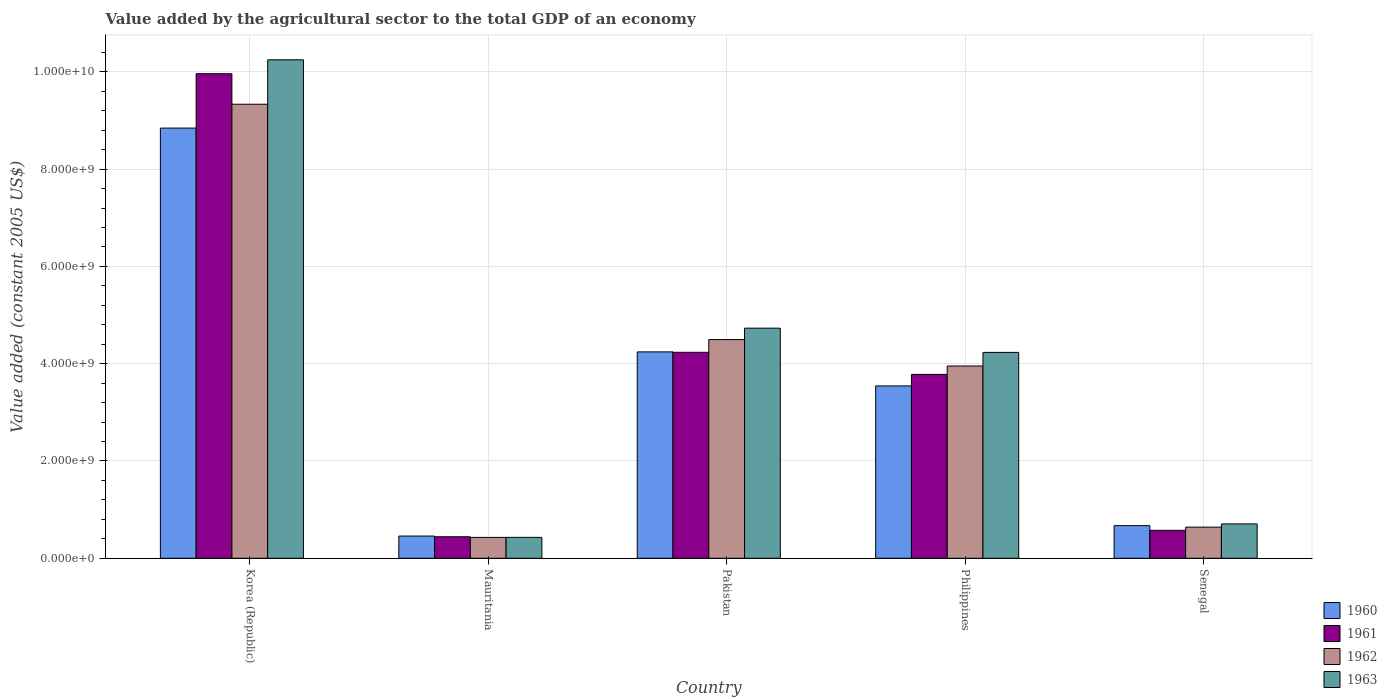How many groups of bars are there?
Provide a short and direct response. 5. Are the number of bars per tick equal to the number of legend labels?
Give a very brief answer. Yes. Are the number of bars on each tick of the X-axis equal?
Make the answer very short. Yes. What is the label of the 2nd group of bars from the left?
Make the answer very short. Mauritania. In how many cases, is the number of bars for a given country not equal to the number of legend labels?
Your answer should be compact. 0. What is the value added by the agricultural sector in 1962 in Philippines?
Provide a succinct answer. 3.95e+09. Across all countries, what is the maximum value added by the agricultural sector in 1963?
Your answer should be very brief. 1.02e+1. Across all countries, what is the minimum value added by the agricultural sector in 1962?
Offer a very short reply. 4.29e+08. In which country was the value added by the agricultural sector in 1960 minimum?
Make the answer very short. Mauritania. What is the total value added by the agricultural sector in 1960 in the graph?
Your answer should be very brief. 1.78e+1. What is the difference between the value added by the agricultural sector in 1962 in Mauritania and that in Senegal?
Provide a short and direct response. -2.11e+08. What is the difference between the value added by the agricultural sector in 1960 in Mauritania and the value added by the agricultural sector in 1961 in Pakistan?
Make the answer very short. -3.78e+09. What is the average value added by the agricultural sector in 1960 per country?
Your response must be concise. 3.55e+09. What is the difference between the value added by the agricultural sector of/in 1962 and value added by the agricultural sector of/in 1963 in Mauritania?
Provide a succinct answer. -7.06e+05. In how many countries, is the value added by the agricultural sector in 1963 greater than 800000000 US$?
Keep it short and to the point. 3. What is the ratio of the value added by the agricultural sector in 1962 in Korea (Republic) to that in Pakistan?
Your answer should be very brief. 2.08. What is the difference between the highest and the second highest value added by the agricultural sector in 1963?
Your answer should be very brief. 5.52e+09. What is the difference between the highest and the lowest value added by the agricultural sector in 1960?
Your answer should be compact. 8.39e+09. Is the sum of the value added by the agricultural sector in 1963 in Pakistan and Senegal greater than the maximum value added by the agricultural sector in 1960 across all countries?
Make the answer very short. No. Is it the case that in every country, the sum of the value added by the agricultural sector in 1961 and value added by the agricultural sector in 1963 is greater than the value added by the agricultural sector in 1960?
Your answer should be compact. Yes. How many bars are there?
Your response must be concise. 20. Are all the bars in the graph horizontal?
Your answer should be very brief. No. What is the difference between two consecutive major ticks on the Y-axis?
Make the answer very short. 2.00e+09. Are the values on the major ticks of Y-axis written in scientific E-notation?
Make the answer very short. Yes. How many legend labels are there?
Ensure brevity in your answer.  4. What is the title of the graph?
Your response must be concise. Value added by the agricultural sector to the total GDP of an economy. Does "1963" appear as one of the legend labels in the graph?
Make the answer very short. Yes. What is the label or title of the Y-axis?
Make the answer very short. Value added (constant 2005 US$). What is the Value added (constant 2005 US$) in 1960 in Korea (Republic)?
Make the answer very short. 8.84e+09. What is the Value added (constant 2005 US$) of 1961 in Korea (Republic)?
Offer a terse response. 9.96e+09. What is the Value added (constant 2005 US$) of 1962 in Korea (Republic)?
Your answer should be compact. 9.33e+09. What is the Value added (constant 2005 US$) in 1963 in Korea (Republic)?
Provide a short and direct response. 1.02e+1. What is the Value added (constant 2005 US$) in 1960 in Mauritania?
Ensure brevity in your answer.  4.57e+08. What is the Value added (constant 2005 US$) of 1961 in Mauritania?
Offer a very short reply. 4.42e+08. What is the Value added (constant 2005 US$) of 1962 in Mauritania?
Make the answer very short. 4.29e+08. What is the Value added (constant 2005 US$) of 1963 in Mauritania?
Provide a short and direct response. 4.30e+08. What is the Value added (constant 2005 US$) of 1960 in Pakistan?
Provide a short and direct response. 4.24e+09. What is the Value added (constant 2005 US$) of 1961 in Pakistan?
Give a very brief answer. 4.23e+09. What is the Value added (constant 2005 US$) in 1962 in Pakistan?
Provide a succinct answer. 4.50e+09. What is the Value added (constant 2005 US$) in 1963 in Pakistan?
Offer a terse response. 4.73e+09. What is the Value added (constant 2005 US$) of 1960 in Philippines?
Offer a very short reply. 3.54e+09. What is the Value added (constant 2005 US$) in 1961 in Philippines?
Keep it short and to the point. 3.78e+09. What is the Value added (constant 2005 US$) in 1962 in Philippines?
Offer a terse response. 3.95e+09. What is the Value added (constant 2005 US$) in 1963 in Philippines?
Keep it short and to the point. 4.23e+09. What is the Value added (constant 2005 US$) in 1960 in Senegal?
Give a very brief answer. 6.70e+08. What is the Value added (constant 2005 US$) in 1961 in Senegal?
Provide a succinct answer. 5.74e+08. What is the Value added (constant 2005 US$) of 1962 in Senegal?
Your response must be concise. 6.40e+08. What is the Value added (constant 2005 US$) in 1963 in Senegal?
Your answer should be compact. 7.06e+08. Across all countries, what is the maximum Value added (constant 2005 US$) of 1960?
Your response must be concise. 8.84e+09. Across all countries, what is the maximum Value added (constant 2005 US$) in 1961?
Ensure brevity in your answer.  9.96e+09. Across all countries, what is the maximum Value added (constant 2005 US$) in 1962?
Provide a succinct answer. 9.33e+09. Across all countries, what is the maximum Value added (constant 2005 US$) of 1963?
Give a very brief answer. 1.02e+1. Across all countries, what is the minimum Value added (constant 2005 US$) in 1960?
Offer a very short reply. 4.57e+08. Across all countries, what is the minimum Value added (constant 2005 US$) of 1961?
Provide a succinct answer. 4.42e+08. Across all countries, what is the minimum Value added (constant 2005 US$) of 1962?
Provide a succinct answer. 4.29e+08. Across all countries, what is the minimum Value added (constant 2005 US$) of 1963?
Ensure brevity in your answer.  4.30e+08. What is the total Value added (constant 2005 US$) of 1960 in the graph?
Keep it short and to the point. 1.78e+1. What is the total Value added (constant 2005 US$) of 1961 in the graph?
Offer a very short reply. 1.90e+1. What is the total Value added (constant 2005 US$) in 1962 in the graph?
Make the answer very short. 1.89e+1. What is the total Value added (constant 2005 US$) of 1963 in the graph?
Provide a short and direct response. 2.03e+1. What is the difference between the Value added (constant 2005 US$) in 1960 in Korea (Republic) and that in Mauritania?
Offer a terse response. 8.39e+09. What is the difference between the Value added (constant 2005 US$) in 1961 in Korea (Republic) and that in Mauritania?
Provide a short and direct response. 9.52e+09. What is the difference between the Value added (constant 2005 US$) of 1962 in Korea (Republic) and that in Mauritania?
Your answer should be very brief. 8.91e+09. What is the difference between the Value added (constant 2005 US$) in 1963 in Korea (Republic) and that in Mauritania?
Provide a succinct answer. 9.82e+09. What is the difference between the Value added (constant 2005 US$) in 1960 in Korea (Republic) and that in Pakistan?
Provide a short and direct response. 4.60e+09. What is the difference between the Value added (constant 2005 US$) in 1961 in Korea (Republic) and that in Pakistan?
Your answer should be very brief. 5.73e+09. What is the difference between the Value added (constant 2005 US$) in 1962 in Korea (Republic) and that in Pakistan?
Offer a very short reply. 4.84e+09. What is the difference between the Value added (constant 2005 US$) in 1963 in Korea (Republic) and that in Pakistan?
Provide a succinct answer. 5.52e+09. What is the difference between the Value added (constant 2005 US$) in 1960 in Korea (Republic) and that in Philippines?
Your answer should be compact. 5.30e+09. What is the difference between the Value added (constant 2005 US$) in 1961 in Korea (Republic) and that in Philippines?
Give a very brief answer. 6.18e+09. What is the difference between the Value added (constant 2005 US$) in 1962 in Korea (Republic) and that in Philippines?
Make the answer very short. 5.38e+09. What is the difference between the Value added (constant 2005 US$) in 1963 in Korea (Republic) and that in Philippines?
Make the answer very short. 6.02e+09. What is the difference between the Value added (constant 2005 US$) of 1960 in Korea (Republic) and that in Senegal?
Make the answer very short. 8.17e+09. What is the difference between the Value added (constant 2005 US$) in 1961 in Korea (Republic) and that in Senegal?
Offer a very short reply. 9.39e+09. What is the difference between the Value added (constant 2005 US$) of 1962 in Korea (Republic) and that in Senegal?
Provide a succinct answer. 8.69e+09. What is the difference between the Value added (constant 2005 US$) in 1963 in Korea (Republic) and that in Senegal?
Keep it short and to the point. 9.54e+09. What is the difference between the Value added (constant 2005 US$) in 1960 in Mauritania and that in Pakistan?
Your answer should be very brief. -3.79e+09. What is the difference between the Value added (constant 2005 US$) of 1961 in Mauritania and that in Pakistan?
Your answer should be compact. -3.79e+09. What is the difference between the Value added (constant 2005 US$) in 1962 in Mauritania and that in Pakistan?
Keep it short and to the point. -4.07e+09. What is the difference between the Value added (constant 2005 US$) of 1963 in Mauritania and that in Pakistan?
Make the answer very short. -4.30e+09. What is the difference between the Value added (constant 2005 US$) of 1960 in Mauritania and that in Philippines?
Your answer should be compact. -3.09e+09. What is the difference between the Value added (constant 2005 US$) in 1961 in Mauritania and that in Philippines?
Give a very brief answer. -3.34e+09. What is the difference between the Value added (constant 2005 US$) of 1962 in Mauritania and that in Philippines?
Offer a terse response. -3.52e+09. What is the difference between the Value added (constant 2005 US$) of 1963 in Mauritania and that in Philippines?
Ensure brevity in your answer.  -3.80e+09. What is the difference between the Value added (constant 2005 US$) in 1960 in Mauritania and that in Senegal?
Make the answer very short. -2.14e+08. What is the difference between the Value added (constant 2005 US$) of 1961 in Mauritania and that in Senegal?
Give a very brief answer. -1.32e+08. What is the difference between the Value added (constant 2005 US$) in 1962 in Mauritania and that in Senegal?
Ensure brevity in your answer.  -2.11e+08. What is the difference between the Value added (constant 2005 US$) in 1963 in Mauritania and that in Senegal?
Your answer should be compact. -2.77e+08. What is the difference between the Value added (constant 2005 US$) of 1960 in Pakistan and that in Philippines?
Make the answer very short. 7.00e+08. What is the difference between the Value added (constant 2005 US$) in 1961 in Pakistan and that in Philippines?
Offer a very short reply. 4.54e+08. What is the difference between the Value added (constant 2005 US$) in 1962 in Pakistan and that in Philippines?
Offer a very short reply. 5.44e+08. What is the difference between the Value added (constant 2005 US$) of 1963 in Pakistan and that in Philippines?
Keep it short and to the point. 4.98e+08. What is the difference between the Value added (constant 2005 US$) of 1960 in Pakistan and that in Senegal?
Offer a terse response. 3.57e+09. What is the difference between the Value added (constant 2005 US$) of 1961 in Pakistan and that in Senegal?
Give a very brief answer. 3.66e+09. What is the difference between the Value added (constant 2005 US$) of 1962 in Pakistan and that in Senegal?
Make the answer very short. 3.86e+09. What is the difference between the Value added (constant 2005 US$) in 1963 in Pakistan and that in Senegal?
Ensure brevity in your answer.  4.02e+09. What is the difference between the Value added (constant 2005 US$) in 1960 in Philippines and that in Senegal?
Provide a succinct answer. 2.87e+09. What is the difference between the Value added (constant 2005 US$) of 1961 in Philippines and that in Senegal?
Your answer should be very brief. 3.21e+09. What is the difference between the Value added (constant 2005 US$) of 1962 in Philippines and that in Senegal?
Offer a terse response. 3.31e+09. What is the difference between the Value added (constant 2005 US$) of 1963 in Philippines and that in Senegal?
Ensure brevity in your answer.  3.53e+09. What is the difference between the Value added (constant 2005 US$) in 1960 in Korea (Republic) and the Value added (constant 2005 US$) in 1961 in Mauritania?
Keep it short and to the point. 8.40e+09. What is the difference between the Value added (constant 2005 US$) in 1960 in Korea (Republic) and the Value added (constant 2005 US$) in 1962 in Mauritania?
Ensure brevity in your answer.  8.41e+09. What is the difference between the Value added (constant 2005 US$) of 1960 in Korea (Republic) and the Value added (constant 2005 US$) of 1963 in Mauritania?
Ensure brevity in your answer.  8.41e+09. What is the difference between the Value added (constant 2005 US$) of 1961 in Korea (Republic) and the Value added (constant 2005 US$) of 1962 in Mauritania?
Offer a very short reply. 9.53e+09. What is the difference between the Value added (constant 2005 US$) in 1961 in Korea (Republic) and the Value added (constant 2005 US$) in 1963 in Mauritania?
Provide a short and direct response. 9.53e+09. What is the difference between the Value added (constant 2005 US$) of 1962 in Korea (Republic) and the Value added (constant 2005 US$) of 1963 in Mauritania?
Your response must be concise. 8.90e+09. What is the difference between the Value added (constant 2005 US$) in 1960 in Korea (Republic) and the Value added (constant 2005 US$) in 1961 in Pakistan?
Make the answer very short. 4.61e+09. What is the difference between the Value added (constant 2005 US$) in 1960 in Korea (Republic) and the Value added (constant 2005 US$) in 1962 in Pakistan?
Your answer should be very brief. 4.35e+09. What is the difference between the Value added (constant 2005 US$) of 1960 in Korea (Republic) and the Value added (constant 2005 US$) of 1963 in Pakistan?
Offer a terse response. 4.11e+09. What is the difference between the Value added (constant 2005 US$) in 1961 in Korea (Republic) and the Value added (constant 2005 US$) in 1962 in Pakistan?
Provide a succinct answer. 5.46e+09. What is the difference between the Value added (constant 2005 US$) of 1961 in Korea (Republic) and the Value added (constant 2005 US$) of 1963 in Pakistan?
Your answer should be compact. 5.23e+09. What is the difference between the Value added (constant 2005 US$) in 1962 in Korea (Republic) and the Value added (constant 2005 US$) in 1963 in Pakistan?
Your answer should be compact. 4.60e+09. What is the difference between the Value added (constant 2005 US$) in 1960 in Korea (Republic) and the Value added (constant 2005 US$) in 1961 in Philippines?
Provide a succinct answer. 5.06e+09. What is the difference between the Value added (constant 2005 US$) in 1960 in Korea (Republic) and the Value added (constant 2005 US$) in 1962 in Philippines?
Keep it short and to the point. 4.89e+09. What is the difference between the Value added (constant 2005 US$) of 1960 in Korea (Republic) and the Value added (constant 2005 US$) of 1963 in Philippines?
Keep it short and to the point. 4.61e+09. What is the difference between the Value added (constant 2005 US$) in 1961 in Korea (Republic) and the Value added (constant 2005 US$) in 1962 in Philippines?
Provide a short and direct response. 6.01e+09. What is the difference between the Value added (constant 2005 US$) in 1961 in Korea (Republic) and the Value added (constant 2005 US$) in 1963 in Philippines?
Offer a very short reply. 5.73e+09. What is the difference between the Value added (constant 2005 US$) of 1962 in Korea (Republic) and the Value added (constant 2005 US$) of 1963 in Philippines?
Provide a short and direct response. 5.10e+09. What is the difference between the Value added (constant 2005 US$) in 1960 in Korea (Republic) and the Value added (constant 2005 US$) in 1961 in Senegal?
Your answer should be very brief. 8.27e+09. What is the difference between the Value added (constant 2005 US$) in 1960 in Korea (Republic) and the Value added (constant 2005 US$) in 1962 in Senegal?
Provide a succinct answer. 8.20e+09. What is the difference between the Value added (constant 2005 US$) of 1960 in Korea (Republic) and the Value added (constant 2005 US$) of 1963 in Senegal?
Your answer should be compact. 8.14e+09. What is the difference between the Value added (constant 2005 US$) of 1961 in Korea (Republic) and the Value added (constant 2005 US$) of 1962 in Senegal?
Keep it short and to the point. 9.32e+09. What is the difference between the Value added (constant 2005 US$) of 1961 in Korea (Republic) and the Value added (constant 2005 US$) of 1963 in Senegal?
Offer a very short reply. 9.25e+09. What is the difference between the Value added (constant 2005 US$) of 1962 in Korea (Republic) and the Value added (constant 2005 US$) of 1963 in Senegal?
Offer a very short reply. 8.63e+09. What is the difference between the Value added (constant 2005 US$) of 1960 in Mauritania and the Value added (constant 2005 US$) of 1961 in Pakistan?
Your response must be concise. -3.78e+09. What is the difference between the Value added (constant 2005 US$) in 1960 in Mauritania and the Value added (constant 2005 US$) in 1962 in Pakistan?
Ensure brevity in your answer.  -4.04e+09. What is the difference between the Value added (constant 2005 US$) in 1960 in Mauritania and the Value added (constant 2005 US$) in 1963 in Pakistan?
Provide a short and direct response. -4.27e+09. What is the difference between the Value added (constant 2005 US$) in 1961 in Mauritania and the Value added (constant 2005 US$) in 1962 in Pakistan?
Provide a succinct answer. -4.05e+09. What is the difference between the Value added (constant 2005 US$) in 1961 in Mauritania and the Value added (constant 2005 US$) in 1963 in Pakistan?
Ensure brevity in your answer.  -4.29e+09. What is the difference between the Value added (constant 2005 US$) of 1962 in Mauritania and the Value added (constant 2005 US$) of 1963 in Pakistan?
Your response must be concise. -4.30e+09. What is the difference between the Value added (constant 2005 US$) in 1960 in Mauritania and the Value added (constant 2005 US$) in 1961 in Philippines?
Offer a terse response. -3.32e+09. What is the difference between the Value added (constant 2005 US$) in 1960 in Mauritania and the Value added (constant 2005 US$) in 1962 in Philippines?
Your answer should be compact. -3.50e+09. What is the difference between the Value added (constant 2005 US$) in 1960 in Mauritania and the Value added (constant 2005 US$) in 1963 in Philippines?
Your answer should be compact. -3.78e+09. What is the difference between the Value added (constant 2005 US$) of 1961 in Mauritania and the Value added (constant 2005 US$) of 1962 in Philippines?
Keep it short and to the point. -3.51e+09. What is the difference between the Value added (constant 2005 US$) in 1961 in Mauritania and the Value added (constant 2005 US$) in 1963 in Philippines?
Provide a succinct answer. -3.79e+09. What is the difference between the Value added (constant 2005 US$) of 1962 in Mauritania and the Value added (constant 2005 US$) of 1963 in Philippines?
Provide a short and direct response. -3.80e+09. What is the difference between the Value added (constant 2005 US$) in 1960 in Mauritania and the Value added (constant 2005 US$) in 1961 in Senegal?
Your response must be concise. -1.18e+08. What is the difference between the Value added (constant 2005 US$) in 1960 in Mauritania and the Value added (constant 2005 US$) in 1962 in Senegal?
Make the answer very short. -1.83e+08. What is the difference between the Value added (constant 2005 US$) in 1960 in Mauritania and the Value added (constant 2005 US$) in 1963 in Senegal?
Your response must be concise. -2.50e+08. What is the difference between the Value added (constant 2005 US$) of 1961 in Mauritania and the Value added (constant 2005 US$) of 1962 in Senegal?
Your response must be concise. -1.97e+08. What is the difference between the Value added (constant 2005 US$) in 1961 in Mauritania and the Value added (constant 2005 US$) in 1963 in Senegal?
Give a very brief answer. -2.64e+08. What is the difference between the Value added (constant 2005 US$) in 1962 in Mauritania and the Value added (constant 2005 US$) in 1963 in Senegal?
Offer a very short reply. -2.77e+08. What is the difference between the Value added (constant 2005 US$) in 1960 in Pakistan and the Value added (constant 2005 US$) in 1961 in Philippines?
Make the answer very short. 4.62e+08. What is the difference between the Value added (constant 2005 US$) in 1960 in Pakistan and the Value added (constant 2005 US$) in 1962 in Philippines?
Offer a terse response. 2.90e+08. What is the difference between the Value added (constant 2005 US$) in 1960 in Pakistan and the Value added (constant 2005 US$) in 1963 in Philippines?
Give a very brief answer. 1.07e+07. What is the difference between the Value added (constant 2005 US$) in 1961 in Pakistan and the Value added (constant 2005 US$) in 1962 in Philippines?
Make the answer very short. 2.82e+08. What is the difference between the Value added (constant 2005 US$) in 1961 in Pakistan and the Value added (constant 2005 US$) in 1963 in Philippines?
Your response must be concise. 2.10e+06. What is the difference between the Value added (constant 2005 US$) of 1962 in Pakistan and the Value added (constant 2005 US$) of 1963 in Philippines?
Provide a succinct answer. 2.64e+08. What is the difference between the Value added (constant 2005 US$) of 1960 in Pakistan and the Value added (constant 2005 US$) of 1961 in Senegal?
Provide a short and direct response. 3.67e+09. What is the difference between the Value added (constant 2005 US$) of 1960 in Pakistan and the Value added (constant 2005 US$) of 1962 in Senegal?
Ensure brevity in your answer.  3.60e+09. What is the difference between the Value added (constant 2005 US$) in 1960 in Pakistan and the Value added (constant 2005 US$) in 1963 in Senegal?
Keep it short and to the point. 3.54e+09. What is the difference between the Value added (constant 2005 US$) in 1961 in Pakistan and the Value added (constant 2005 US$) in 1962 in Senegal?
Provide a short and direct response. 3.59e+09. What is the difference between the Value added (constant 2005 US$) in 1961 in Pakistan and the Value added (constant 2005 US$) in 1963 in Senegal?
Make the answer very short. 3.53e+09. What is the difference between the Value added (constant 2005 US$) in 1962 in Pakistan and the Value added (constant 2005 US$) in 1963 in Senegal?
Offer a terse response. 3.79e+09. What is the difference between the Value added (constant 2005 US$) of 1960 in Philippines and the Value added (constant 2005 US$) of 1961 in Senegal?
Make the answer very short. 2.97e+09. What is the difference between the Value added (constant 2005 US$) in 1960 in Philippines and the Value added (constant 2005 US$) in 1962 in Senegal?
Ensure brevity in your answer.  2.90e+09. What is the difference between the Value added (constant 2005 US$) in 1960 in Philippines and the Value added (constant 2005 US$) in 1963 in Senegal?
Make the answer very short. 2.84e+09. What is the difference between the Value added (constant 2005 US$) of 1961 in Philippines and the Value added (constant 2005 US$) of 1962 in Senegal?
Ensure brevity in your answer.  3.14e+09. What is the difference between the Value added (constant 2005 US$) in 1961 in Philippines and the Value added (constant 2005 US$) in 1963 in Senegal?
Provide a succinct answer. 3.07e+09. What is the difference between the Value added (constant 2005 US$) in 1962 in Philippines and the Value added (constant 2005 US$) in 1963 in Senegal?
Provide a succinct answer. 3.25e+09. What is the average Value added (constant 2005 US$) of 1960 per country?
Make the answer very short. 3.55e+09. What is the average Value added (constant 2005 US$) in 1961 per country?
Make the answer very short. 3.80e+09. What is the average Value added (constant 2005 US$) of 1962 per country?
Provide a short and direct response. 3.77e+09. What is the average Value added (constant 2005 US$) of 1963 per country?
Provide a short and direct response. 4.07e+09. What is the difference between the Value added (constant 2005 US$) in 1960 and Value added (constant 2005 US$) in 1961 in Korea (Republic)?
Your response must be concise. -1.12e+09. What is the difference between the Value added (constant 2005 US$) of 1960 and Value added (constant 2005 US$) of 1962 in Korea (Republic)?
Offer a terse response. -4.90e+08. What is the difference between the Value added (constant 2005 US$) in 1960 and Value added (constant 2005 US$) in 1963 in Korea (Republic)?
Give a very brief answer. -1.40e+09. What is the difference between the Value added (constant 2005 US$) of 1961 and Value added (constant 2005 US$) of 1962 in Korea (Republic)?
Give a very brief answer. 6.27e+08. What is the difference between the Value added (constant 2005 US$) of 1961 and Value added (constant 2005 US$) of 1963 in Korea (Republic)?
Provide a short and direct response. -2.87e+08. What is the difference between the Value added (constant 2005 US$) of 1962 and Value added (constant 2005 US$) of 1963 in Korea (Republic)?
Provide a succinct answer. -9.14e+08. What is the difference between the Value added (constant 2005 US$) of 1960 and Value added (constant 2005 US$) of 1961 in Mauritania?
Provide a short and direct response. 1.44e+07. What is the difference between the Value added (constant 2005 US$) of 1960 and Value added (constant 2005 US$) of 1962 in Mauritania?
Provide a short and direct response. 2.75e+07. What is the difference between the Value added (constant 2005 US$) in 1960 and Value added (constant 2005 US$) in 1963 in Mauritania?
Provide a short and direct response. 2.68e+07. What is the difference between the Value added (constant 2005 US$) in 1961 and Value added (constant 2005 US$) in 1962 in Mauritania?
Your answer should be very brief. 1.31e+07. What is the difference between the Value added (constant 2005 US$) of 1961 and Value added (constant 2005 US$) of 1963 in Mauritania?
Your answer should be compact. 1.24e+07. What is the difference between the Value added (constant 2005 US$) in 1962 and Value added (constant 2005 US$) in 1963 in Mauritania?
Your answer should be very brief. -7.06e+05. What is the difference between the Value added (constant 2005 US$) of 1960 and Value added (constant 2005 US$) of 1961 in Pakistan?
Your answer should be very brief. 8.56e+06. What is the difference between the Value added (constant 2005 US$) of 1960 and Value added (constant 2005 US$) of 1962 in Pakistan?
Give a very brief answer. -2.53e+08. What is the difference between the Value added (constant 2005 US$) of 1960 and Value added (constant 2005 US$) of 1963 in Pakistan?
Your answer should be very brief. -4.87e+08. What is the difference between the Value added (constant 2005 US$) of 1961 and Value added (constant 2005 US$) of 1962 in Pakistan?
Make the answer very short. -2.62e+08. What is the difference between the Value added (constant 2005 US$) of 1961 and Value added (constant 2005 US$) of 1963 in Pakistan?
Your answer should be very brief. -4.96e+08. What is the difference between the Value added (constant 2005 US$) of 1962 and Value added (constant 2005 US$) of 1963 in Pakistan?
Give a very brief answer. -2.34e+08. What is the difference between the Value added (constant 2005 US$) in 1960 and Value added (constant 2005 US$) in 1961 in Philippines?
Your answer should be very brief. -2.37e+08. What is the difference between the Value added (constant 2005 US$) in 1960 and Value added (constant 2005 US$) in 1962 in Philippines?
Keep it short and to the point. -4.09e+08. What is the difference between the Value added (constant 2005 US$) in 1960 and Value added (constant 2005 US$) in 1963 in Philippines?
Make the answer very short. -6.89e+08. What is the difference between the Value added (constant 2005 US$) in 1961 and Value added (constant 2005 US$) in 1962 in Philippines?
Your response must be concise. -1.72e+08. What is the difference between the Value added (constant 2005 US$) in 1961 and Value added (constant 2005 US$) in 1963 in Philippines?
Ensure brevity in your answer.  -4.52e+08. What is the difference between the Value added (constant 2005 US$) in 1962 and Value added (constant 2005 US$) in 1963 in Philippines?
Ensure brevity in your answer.  -2.80e+08. What is the difference between the Value added (constant 2005 US$) in 1960 and Value added (constant 2005 US$) in 1961 in Senegal?
Your response must be concise. 9.60e+07. What is the difference between the Value added (constant 2005 US$) of 1960 and Value added (constant 2005 US$) of 1962 in Senegal?
Give a very brief answer. 3.06e+07. What is the difference between the Value added (constant 2005 US$) of 1960 and Value added (constant 2005 US$) of 1963 in Senegal?
Make the answer very short. -3.60e+07. What is the difference between the Value added (constant 2005 US$) in 1961 and Value added (constant 2005 US$) in 1962 in Senegal?
Make the answer very short. -6.53e+07. What is the difference between the Value added (constant 2005 US$) of 1961 and Value added (constant 2005 US$) of 1963 in Senegal?
Your response must be concise. -1.32e+08. What is the difference between the Value added (constant 2005 US$) in 1962 and Value added (constant 2005 US$) in 1963 in Senegal?
Ensure brevity in your answer.  -6.67e+07. What is the ratio of the Value added (constant 2005 US$) in 1960 in Korea (Republic) to that in Mauritania?
Your answer should be very brief. 19.37. What is the ratio of the Value added (constant 2005 US$) of 1961 in Korea (Republic) to that in Mauritania?
Ensure brevity in your answer.  22.52. What is the ratio of the Value added (constant 2005 US$) of 1962 in Korea (Republic) to that in Mauritania?
Offer a terse response. 21.75. What is the ratio of the Value added (constant 2005 US$) in 1963 in Korea (Republic) to that in Mauritania?
Ensure brevity in your answer.  23.84. What is the ratio of the Value added (constant 2005 US$) of 1960 in Korea (Republic) to that in Pakistan?
Provide a short and direct response. 2.08. What is the ratio of the Value added (constant 2005 US$) of 1961 in Korea (Republic) to that in Pakistan?
Offer a very short reply. 2.35. What is the ratio of the Value added (constant 2005 US$) of 1962 in Korea (Republic) to that in Pakistan?
Provide a short and direct response. 2.08. What is the ratio of the Value added (constant 2005 US$) of 1963 in Korea (Republic) to that in Pakistan?
Make the answer very short. 2.17. What is the ratio of the Value added (constant 2005 US$) in 1960 in Korea (Republic) to that in Philippines?
Make the answer very short. 2.5. What is the ratio of the Value added (constant 2005 US$) in 1961 in Korea (Republic) to that in Philippines?
Ensure brevity in your answer.  2.63. What is the ratio of the Value added (constant 2005 US$) of 1962 in Korea (Republic) to that in Philippines?
Offer a very short reply. 2.36. What is the ratio of the Value added (constant 2005 US$) in 1963 in Korea (Republic) to that in Philippines?
Keep it short and to the point. 2.42. What is the ratio of the Value added (constant 2005 US$) of 1960 in Korea (Republic) to that in Senegal?
Your answer should be very brief. 13.19. What is the ratio of the Value added (constant 2005 US$) in 1961 in Korea (Republic) to that in Senegal?
Your answer should be compact. 17.34. What is the ratio of the Value added (constant 2005 US$) in 1962 in Korea (Republic) to that in Senegal?
Keep it short and to the point. 14.59. What is the ratio of the Value added (constant 2005 US$) in 1963 in Korea (Republic) to that in Senegal?
Your response must be concise. 14.51. What is the ratio of the Value added (constant 2005 US$) in 1960 in Mauritania to that in Pakistan?
Keep it short and to the point. 0.11. What is the ratio of the Value added (constant 2005 US$) in 1961 in Mauritania to that in Pakistan?
Offer a terse response. 0.1. What is the ratio of the Value added (constant 2005 US$) of 1962 in Mauritania to that in Pakistan?
Your response must be concise. 0.1. What is the ratio of the Value added (constant 2005 US$) of 1963 in Mauritania to that in Pakistan?
Offer a terse response. 0.09. What is the ratio of the Value added (constant 2005 US$) of 1960 in Mauritania to that in Philippines?
Keep it short and to the point. 0.13. What is the ratio of the Value added (constant 2005 US$) in 1961 in Mauritania to that in Philippines?
Offer a terse response. 0.12. What is the ratio of the Value added (constant 2005 US$) in 1962 in Mauritania to that in Philippines?
Your answer should be compact. 0.11. What is the ratio of the Value added (constant 2005 US$) of 1963 in Mauritania to that in Philippines?
Your answer should be very brief. 0.1. What is the ratio of the Value added (constant 2005 US$) in 1960 in Mauritania to that in Senegal?
Make the answer very short. 0.68. What is the ratio of the Value added (constant 2005 US$) of 1961 in Mauritania to that in Senegal?
Provide a succinct answer. 0.77. What is the ratio of the Value added (constant 2005 US$) in 1962 in Mauritania to that in Senegal?
Ensure brevity in your answer.  0.67. What is the ratio of the Value added (constant 2005 US$) in 1963 in Mauritania to that in Senegal?
Provide a short and direct response. 0.61. What is the ratio of the Value added (constant 2005 US$) in 1960 in Pakistan to that in Philippines?
Keep it short and to the point. 1.2. What is the ratio of the Value added (constant 2005 US$) in 1961 in Pakistan to that in Philippines?
Offer a terse response. 1.12. What is the ratio of the Value added (constant 2005 US$) in 1962 in Pakistan to that in Philippines?
Keep it short and to the point. 1.14. What is the ratio of the Value added (constant 2005 US$) of 1963 in Pakistan to that in Philippines?
Provide a succinct answer. 1.12. What is the ratio of the Value added (constant 2005 US$) of 1960 in Pakistan to that in Senegal?
Offer a terse response. 6.33. What is the ratio of the Value added (constant 2005 US$) of 1961 in Pakistan to that in Senegal?
Your response must be concise. 7.37. What is the ratio of the Value added (constant 2005 US$) in 1962 in Pakistan to that in Senegal?
Your answer should be very brief. 7.03. What is the ratio of the Value added (constant 2005 US$) in 1963 in Pakistan to that in Senegal?
Ensure brevity in your answer.  6.7. What is the ratio of the Value added (constant 2005 US$) in 1960 in Philippines to that in Senegal?
Keep it short and to the point. 5.29. What is the ratio of the Value added (constant 2005 US$) in 1961 in Philippines to that in Senegal?
Provide a succinct answer. 6.58. What is the ratio of the Value added (constant 2005 US$) in 1962 in Philippines to that in Senegal?
Make the answer very short. 6.18. What is the ratio of the Value added (constant 2005 US$) of 1963 in Philippines to that in Senegal?
Your answer should be compact. 5.99. What is the difference between the highest and the second highest Value added (constant 2005 US$) in 1960?
Offer a very short reply. 4.60e+09. What is the difference between the highest and the second highest Value added (constant 2005 US$) in 1961?
Offer a terse response. 5.73e+09. What is the difference between the highest and the second highest Value added (constant 2005 US$) in 1962?
Offer a very short reply. 4.84e+09. What is the difference between the highest and the second highest Value added (constant 2005 US$) of 1963?
Give a very brief answer. 5.52e+09. What is the difference between the highest and the lowest Value added (constant 2005 US$) in 1960?
Keep it short and to the point. 8.39e+09. What is the difference between the highest and the lowest Value added (constant 2005 US$) of 1961?
Your answer should be compact. 9.52e+09. What is the difference between the highest and the lowest Value added (constant 2005 US$) in 1962?
Give a very brief answer. 8.91e+09. What is the difference between the highest and the lowest Value added (constant 2005 US$) in 1963?
Provide a short and direct response. 9.82e+09. 